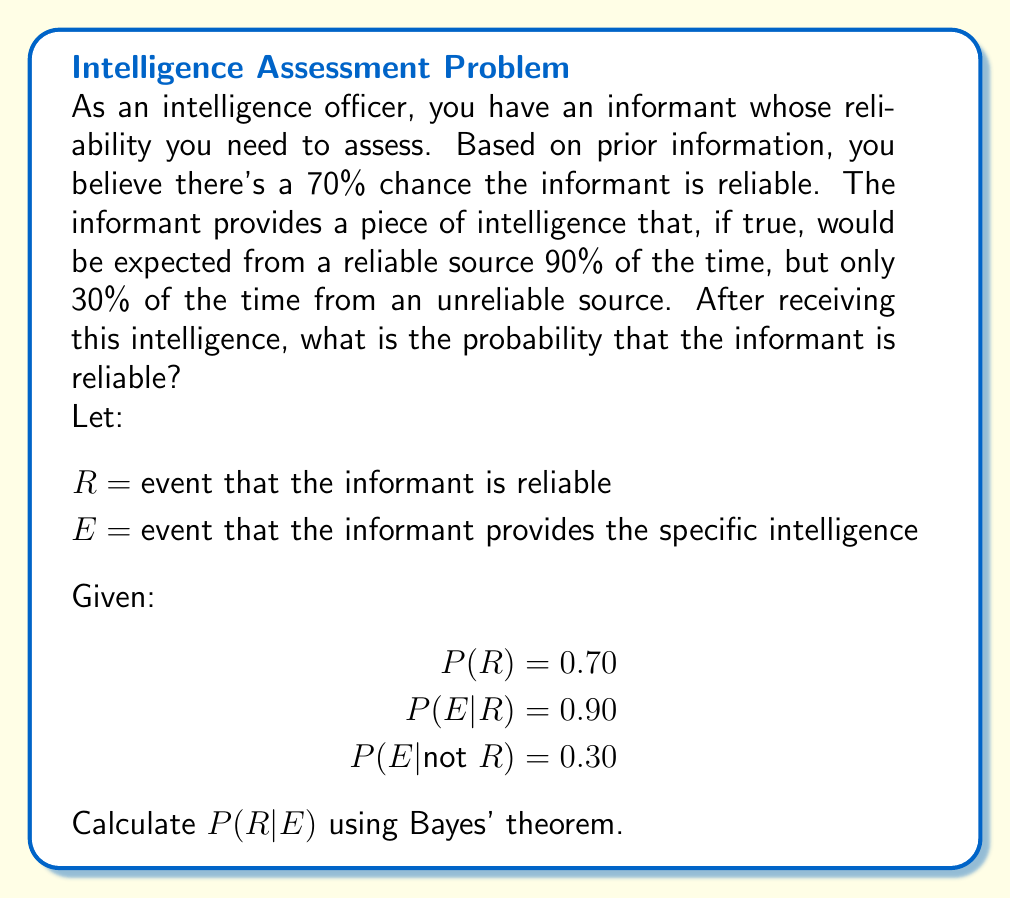What is the answer to this math problem? To solve this problem, we'll use Bayes' theorem:

$$P(R|E) = \frac{P(E|R) \cdot P(R)}{P(E)}$$

Step 1: We're given $P(R)$, $P(E|R)$, and $P(E|\text{not }R)$. We need to calculate $P(E)$.

Step 2: Calculate $P(E)$ using the law of total probability:
$$P(E) = P(E|R) \cdot P(R) + P(E|\text{not }R) \cdot P(\text{not }R)$$
$$P(E) = 0.90 \cdot 0.70 + 0.30 \cdot (1 - 0.70)$$
$$P(E) = 0.63 + 0.09 = 0.72$$

Step 3: Apply Bayes' theorem:
$$P(R|E) = \frac{0.90 \cdot 0.70}{0.72}$$

Step 4: Calculate the final probability:
$$P(R|E) = \frac{0.63}{0.72} \approx 0.875$$

Therefore, after receiving the intelligence, the probability that the informant is reliable is approximately 0.875 or 87.5%.
Answer: 0.875 (or 87.5%) 